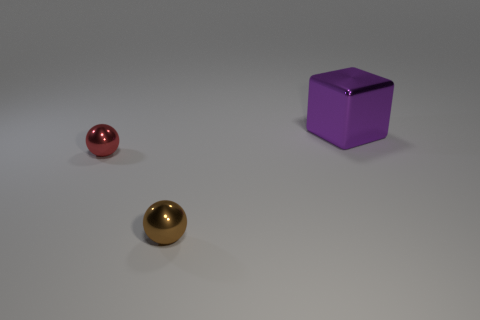Add 2 rubber blocks. How many objects exist? 5 Subtract all cubes. How many objects are left? 2 Subtract 1 purple cubes. How many objects are left? 2 Subtract all balls. Subtract all red shiny objects. How many objects are left? 0 Add 2 purple objects. How many purple objects are left? 3 Add 2 big purple metallic objects. How many big purple metallic objects exist? 3 